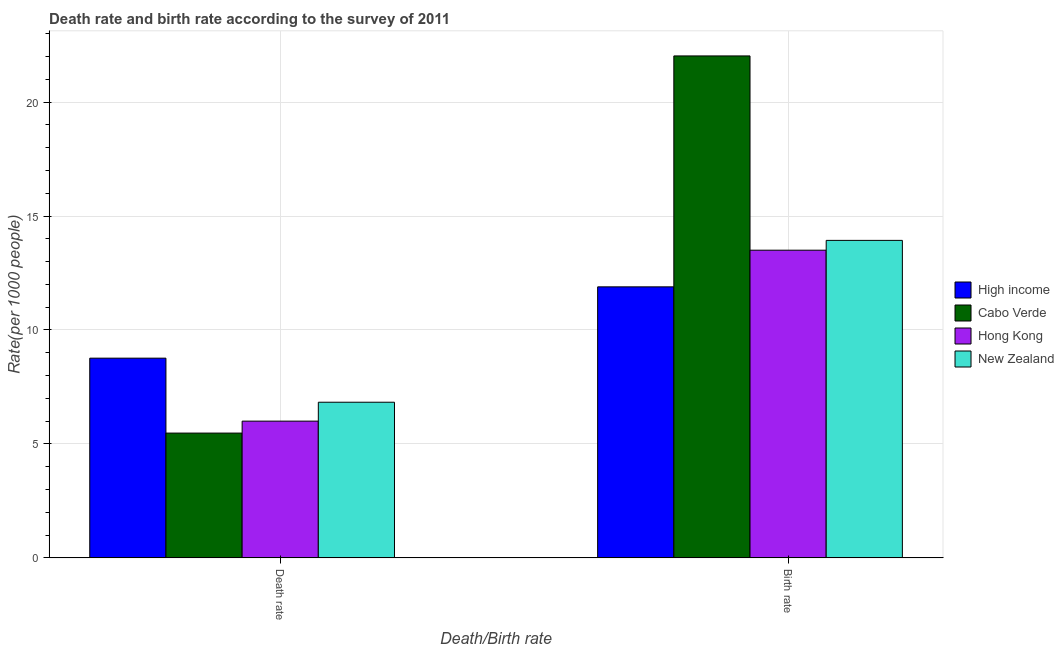Are the number of bars per tick equal to the number of legend labels?
Make the answer very short. Yes. How many bars are there on the 1st tick from the left?
Ensure brevity in your answer.  4. How many bars are there on the 1st tick from the right?
Ensure brevity in your answer.  4. What is the label of the 2nd group of bars from the left?
Offer a terse response. Birth rate. Across all countries, what is the maximum death rate?
Keep it short and to the point. 8.76. Across all countries, what is the minimum death rate?
Make the answer very short. 5.48. In which country was the birth rate maximum?
Provide a succinct answer. Cabo Verde. In which country was the birth rate minimum?
Your answer should be very brief. High income. What is the total birth rate in the graph?
Make the answer very short. 61.34. What is the difference between the birth rate in New Zealand and that in Hong Kong?
Provide a short and direct response. 0.43. What is the difference between the birth rate in Cabo Verde and the death rate in New Zealand?
Keep it short and to the point. 15.19. What is the average death rate per country?
Give a very brief answer. 6.77. What is the ratio of the death rate in High income to that in Hong Kong?
Ensure brevity in your answer.  1.46. Is the death rate in Cabo Verde less than that in High income?
Provide a short and direct response. Yes. What does the 1st bar from the left in Birth rate represents?
Your answer should be very brief. High income. What does the 2nd bar from the right in Death rate represents?
Your answer should be compact. Hong Kong. What is the difference between two consecutive major ticks on the Y-axis?
Your answer should be compact. 5. Does the graph contain any zero values?
Your response must be concise. No. Where does the legend appear in the graph?
Ensure brevity in your answer.  Center right. How many legend labels are there?
Your answer should be very brief. 4. How are the legend labels stacked?
Offer a terse response. Vertical. What is the title of the graph?
Give a very brief answer. Death rate and birth rate according to the survey of 2011. Does "Philippines" appear as one of the legend labels in the graph?
Offer a very short reply. No. What is the label or title of the X-axis?
Offer a very short reply. Death/Birth rate. What is the label or title of the Y-axis?
Give a very brief answer. Rate(per 1000 people). What is the Rate(per 1000 people) in High income in Death rate?
Your answer should be compact. 8.76. What is the Rate(per 1000 people) of Cabo Verde in Death rate?
Offer a terse response. 5.48. What is the Rate(per 1000 people) of Hong Kong in Death rate?
Offer a very short reply. 6. What is the Rate(per 1000 people) of New Zealand in Death rate?
Your response must be concise. 6.83. What is the Rate(per 1000 people) of High income in Birth rate?
Keep it short and to the point. 11.89. What is the Rate(per 1000 people) of Cabo Verde in Birth rate?
Your answer should be very brief. 22.02. What is the Rate(per 1000 people) in New Zealand in Birth rate?
Provide a short and direct response. 13.93. Across all Death/Birth rate, what is the maximum Rate(per 1000 people) in High income?
Make the answer very short. 11.89. Across all Death/Birth rate, what is the maximum Rate(per 1000 people) of Cabo Verde?
Provide a short and direct response. 22.02. Across all Death/Birth rate, what is the maximum Rate(per 1000 people) of New Zealand?
Give a very brief answer. 13.93. Across all Death/Birth rate, what is the minimum Rate(per 1000 people) of High income?
Offer a very short reply. 8.76. Across all Death/Birth rate, what is the minimum Rate(per 1000 people) of Cabo Verde?
Your answer should be very brief. 5.48. Across all Death/Birth rate, what is the minimum Rate(per 1000 people) in Hong Kong?
Provide a short and direct response. 6. Across all Death/Birth rate, what is the minimum Rate(per 1000 people) of New Zealand?
Make the answer very short. 6.83. What is the total Rate(per 1000 people) in High income in the graph?
Offer a terse response. 20.65. What is the total Rate(per 1000 people) of Cabo Verde in the graph?
Your answer should be compact. 27.5. What is the total Rate(per 1000 people) of New Zealand in the graph?
Make the answer very short. 20.76. What is the difference between the Rate(per 1000 people) of High income in Death rate and that in Birth rate?
Your answer should be very brief. -3.13. What is the difference between the Rate(per 1000 people) of Cabo Verde in Death rate and that in Birth rate?
Provide a succinct answer. -16.55. What is the difference between the Rate(per 1000 people) in Hong Kong in Death rate and that in Birth rate?
Your answer should be very brief. -7.5. What is the difference between the Rate(per 1000 people) in High income in Death rate and the Rate(per 1000 people) in Cabo Verde in Birth rate?
Give a very brief answer. -13.26. What is the difference between the Rate(per 1000 people) of High income in Death rate and the Rate(per 1000 people) of Hong Kong in Birth rate?
Provide a short and direct response. -4.74. What is the difference between the Rate(per 1000 people) in High income in Death rate and the Rate(per 1000 people) in New Zealand in Birth rate?
Your response must be concise. -5.17. What is the difference between the Rate(per 1000 people) of Cabo Verde in Death rate and the Rate(per 1000 people) of Hong Kong in Birth rate?
Provide a succinct answer. -8.02. What is the difference between the Rate(per 1000 people) in Cabo Verde in Death rate and the Rate(per 1000 people) in New Zealand in Birth rate?
Your response must be concise. -8.45. What is the difference between the Rate(per 1000 people) in Hong Kong in Death rate and the Rate(per 1000 people) in New Zealand in Birth rate?
Provide a succinct answer. -7.93. What is the average Rate(per 1000 people) in High income per Death/Birth rate?
Ensure brevity in your answer.  10.33. What is the average Rate(per 1000 people) in Cabo Verde per Death/Birth rate?
Your response must be concise. 13.75. What is the average Rate(per 1000 people) of Hong Kong per Death/Birth rate?
Ensure brevity in your answer.  9.75. What is the average Rate(per 1000 people) of New Zealand per Death/Birth rate?
Keep it short and to the point. 10.38. What is the difference between the Rate(per 1000 people) of High income and Rate(per 1000 people) of Cabo Verde in Death rate?
Your response must be concise. 3.29. What is the difference between the Rate(per 1000 people) of High income and Rate(per 1000 people) of Hong Kong in Death rate?
Your response must be concise. 2.76. What is the difference between the Rate(per 1000 people) in High income and Rate(per 1000 people) in New Zealand in Death rate?
Make the answer very short. 1.93. What is the difference between the Rate(per 1000 people) of Cabo Verde and Rate(per 1000 people) of Hong Kong in Death rate?
Provide a short and direct response. -0.52. What is the difference between the Rate(per 1000 people) of Cabo Verde and Rate(per 1000 people) of New Zealand in Death rate?
Offer a very short reply. -1.35. What is the difference between the Rate(per 1000 people) of Hong Kong and Rate(per 1000 people) of New Zealand in Death rate?
Give a very brief answer. -0.83. What is the difference between the Rate(per 1000 people) of High income and Rate(per 1000 people) of Cabo Verde in Birth rate?
Provide a short and direct response. -10.13. What is the difference between the Rate(per 1000 people) in High income and Rate(per 1000 people) in Hong Kong in Birth rate?
Provide a short and direct response. -1.61. What is the difference between the Rate(per 1000 people) of High income and Rate(per 1000 people) of New Zealand in Birth rate?
Make the answer very short. -2.04. What is the difference between the Rate(per 1000 people) in Cabo Verde and Rate(per 1000 people) in Hong Kong in Birth rate?
Offer a terse response. 8.52. What is the difference between the Rate(per 1000 people) in Cabo Verde and Rate(per 1000 people) in New Zealand in Birth rate?
Offer a terse response. 8.09. What is the difference between the Rate(per 1000 people) in Hong Kong and Rate(per 1000 people) in New Zealand in Birth rate?
Offer a terse response. -0.43. What is the ratio of the Rate(per 1000 people) of High income in Death rate to that in Birth rate?
Make the answer very short. 0.74. What is the ratio of the Rate(per 1000 people) of Cabo Verde in Death rate to that in Birth rate?
Give a very brief answer. 0.25. What is the ratio of the Rate(per 1000 people) of Hong Kong in Death rate to that in Birth rate?
Provide a short and direct response. 0.44. What is the ratio of the Rate(per 1000 people) in New Zealand in Death rate to that in Birth rate?
Ensure brevity in your answer.  0.49. What is the difference between the highest and the second highest Rate(per 1000 people) in High income?
Your response must be concise. 3.13. What is the difference between the highest and the second highest Rate(per 1000 people) in Cabo Verde?
Give a very brief answer. 16.55. What is the difference between the highest and the second highest Rate(per 1000 people) of New Zealand?
Make the answer very short. 7.1. What is the difference between the highest and the lowest Rate(per 1000 people) of High income?
Provide a succinct answer. 3.13. What is the difference between the highest and the lowest Rate(per 1000 people) of Cabo Verde?
Give a very brief answer. 16.55. 